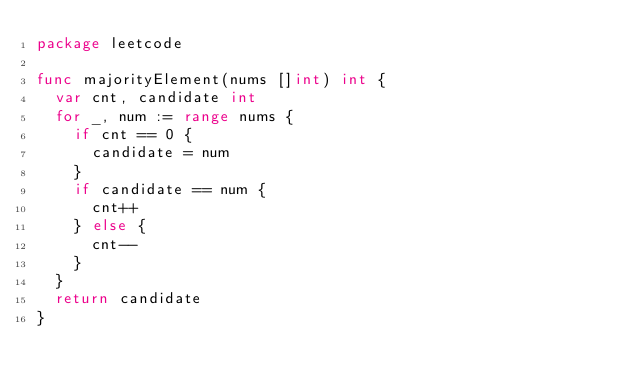<code> <loc_0><loc_0><loc_500><loc_500><_Go_>package leetcode

func majorityElement(nums []int) int {
	var cnt, candidate int
	for _, num := range nums {
		if cnt == 0 {
			candidate = num
		}
		if candidate == num {
			cnt++
		} else {
			cnt--
		}
	}
	return candidate
}
</code> 